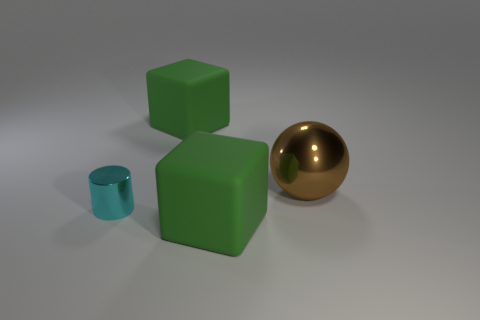What number of tiny blue balls are there?
Your answer should be compact. 0. What number of green rubber objects have the same size as the shiny ball?
Make the answer very short. 2. What is the material of the small cyan cylinder?
Keep it short and to the point. Metal. There is a tiny metal object; is it the same color as the metallic object on the right side of the tiny cyan metal object?
Keep it short and to the point. No. Are there any other things that are the same size as the cylinder?
Your answer should be very brief. No. What is the size of the object that is behind the cyan metallic thing and to the left of the large brown sphere?
Your response must be concise. Large. The cyan object that is the same material as the brown thing is what shape?
Offer a very short reply. Cylinder. Are the big brown object and the big block behind the tiny thing made of the same material?
Ensure brevity in your answer.  No. Is there a big green rubber object that is in front of the cube behind the cyan metallic cylinder?
Give a very brief answer. Yes. There is a green block behind the small shiny thing; what number of green cubes are in front of it?
Your answer should be very brief. 1. 